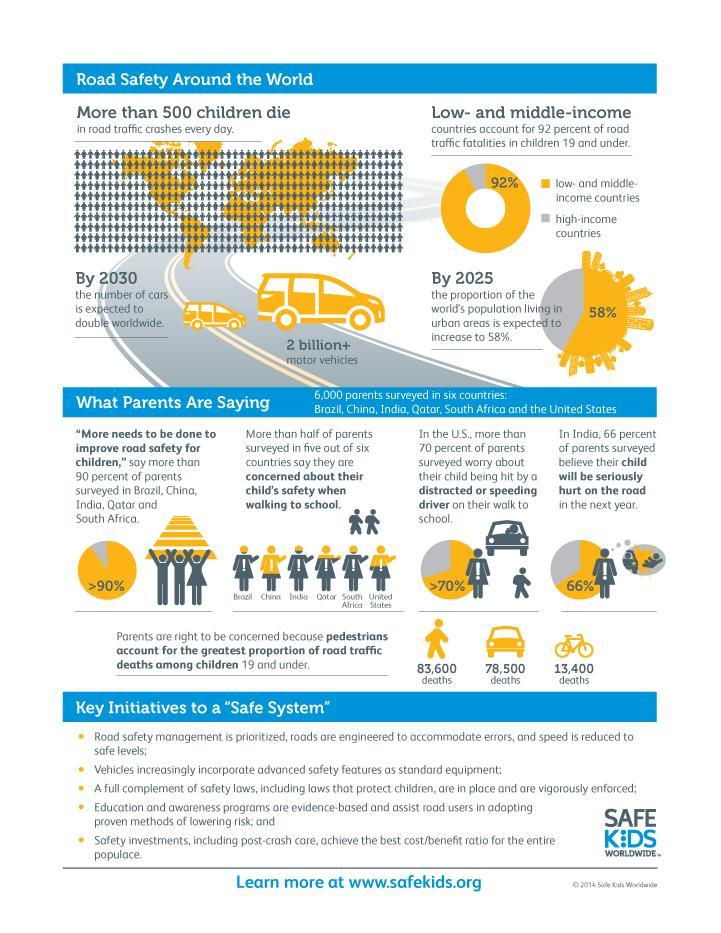how many initiatives for road safety are given in this infographic?
Answer the question with a short phrase. 5 what is the total number of deaths of children caused by bicycle or car accidents? 91900 what is the percentage of road traffic fatalities of children in high-income countries? 8% 